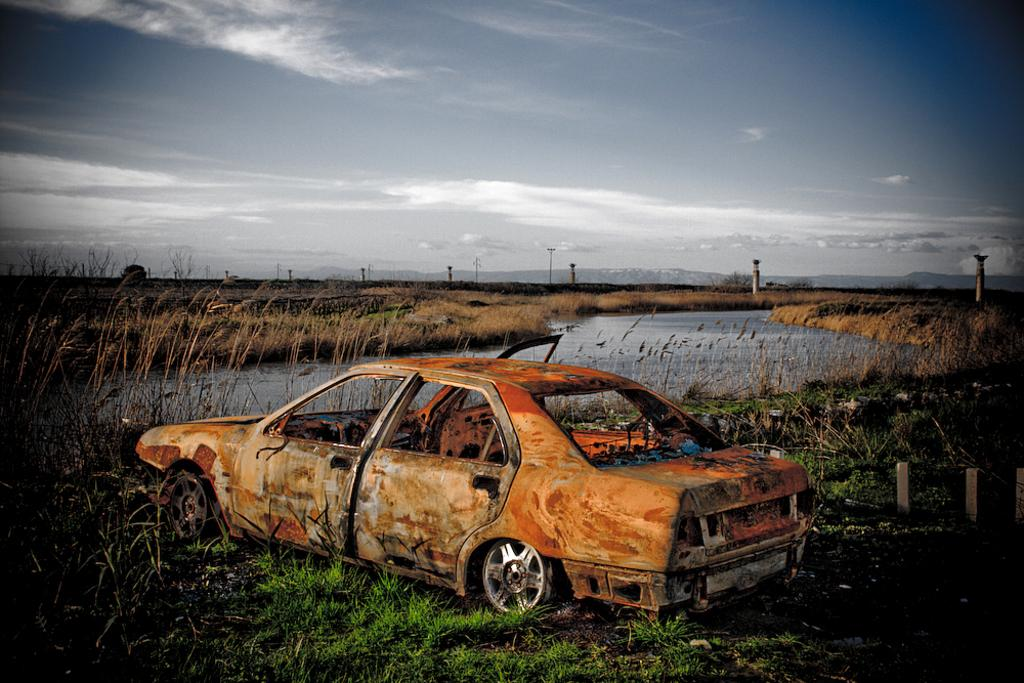What type of ground is visible in the image? There is grass ground in the image. What is located on the grass ground? There is an old vehicle on the grass ground. What can be seen in the background of the image? Water, poles, and clouds are visible in the background of the image. What part of the natural environment is visible in the image? The sky is visible in the background of the image. Can you see a kite flying in the sky in the image? There is no kite visible in the sky in the image. 